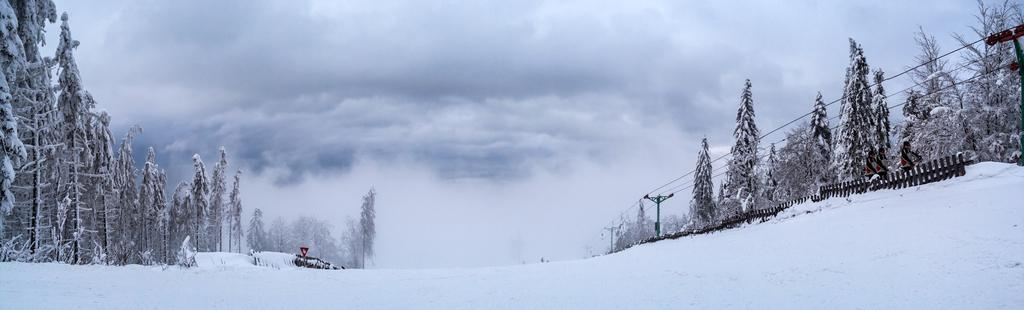What is the primary feature of the landscape in the image? There is snow in the image. What are the people in the image doing? The people are standing on the snow. What structure is present in the image? There is a railing in the image. What type of objects can be seen in the image that are green in color? There are green-colored poles in the image. What else can be seen in the image that is related to infrastructure? There are wires in the image. What type of natural elements are present in the image? There are trees in the image. What is visible in the background of the image? The sky is visible in the background of the image. What type of songs can be heard being sung by the trees in the image? There are no songs being sung by the trees in the image, as trees do not have the ability to sing. 